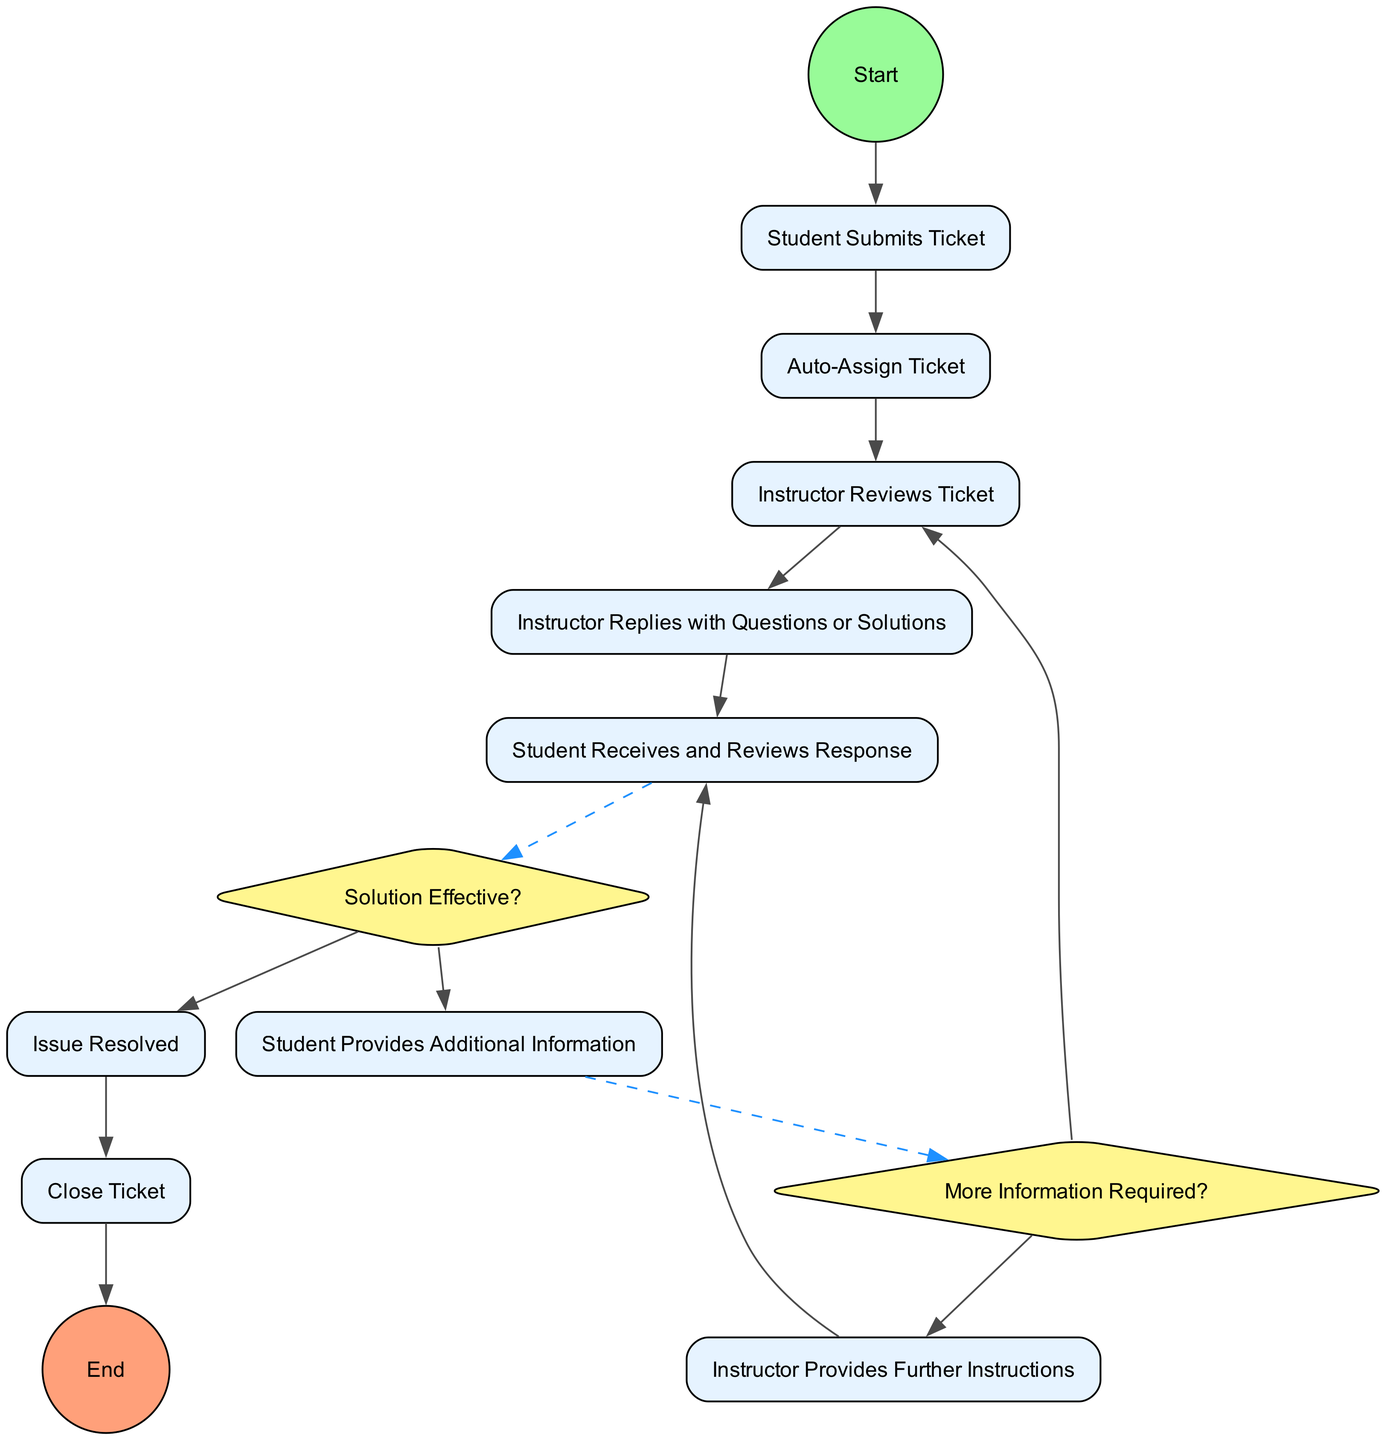What is the first activity in the diagram? The first activity is represented by the starting node, which connects to "Student Submits Ticket." Therefore, the first activity is where the student submits their ticket.
Answer: Student Submits Ticket How many activities are there in total? The diagram lists eight distinct activities that students and instructors engage in during the support ticket process.
Answer: Eight What condition leads to the "Issue Resolved" activity? The condition leading to "Issue Resolved" is when the decision point "Solution Effective?" is answered with "yes," indicating that the provided solution successfully resolved the student's issue.
Answer: Yes Which activity follows "Instructor Provides Further Instructions"? After "Instructor Provides Further Instructions," the flow returns to "Student Receives and Reviews Response," which is where the student again examines the instructor’s guidance.
Answer: Student Receives and Reviews Response What happens if the solution is not effective? If the solution is not effective, the flow directs to "Student Provides Additional Information," where the student gives more details or clarifications about their issue.
Answer: Student Provides Additional Information What is the last step in the diagram? The last step is represented as "Close Ticket," where the instructor finalizes the ticket process by marking it as completed, signaling the end of the support request handling.
Answer: Close Ticket Which decision requires additional information from the student? The decision point labeled "More Information Required?" determines if more details from the student are necessary based on their previous interaction with the instructor.
Answer: More Information Required? What action initiates the entire process? The process begins when the "Student Submits Ticket," meaning the first interaction is initiated by the student submitting their support request.
Answer: Student Submits Ticket 